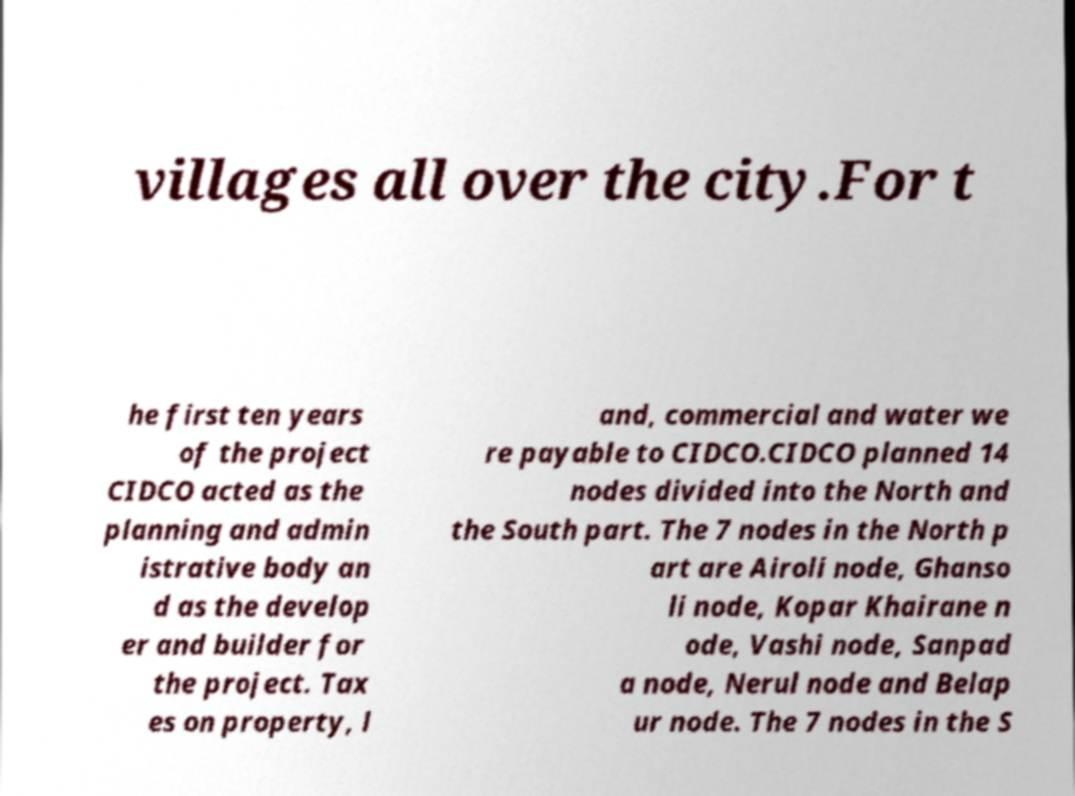There's text embedded in this image that I need extracted. Can you transcribe it verbatim? villages all over the city.For t he first ten years of the project CIDCO acted as the planning and admin istrative body an d as the develop er and builder for the project. Tax es on property, l and, commercial and water we re payable to CIDCO.CIDCO planned 14 nodes divided into the North and the South part. The 7 nodes in the North p art are Airoli node, Ghanso li node, Kopar Khairane n ode, Vashi node, Sanpad a node, Nerul node and Belap ur node. The 7 nodes in the S 